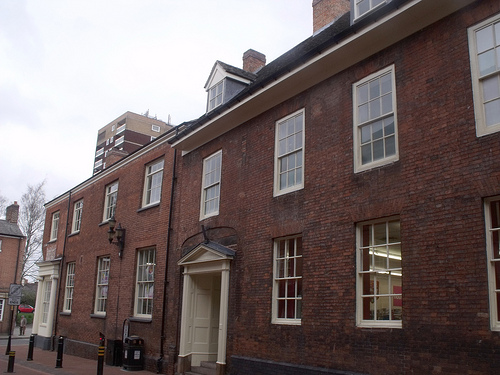<image>
Can you confirm if the door is to the left of the window? Yes. From this viewpoint, the door is positioned to the left side relative to the window. 